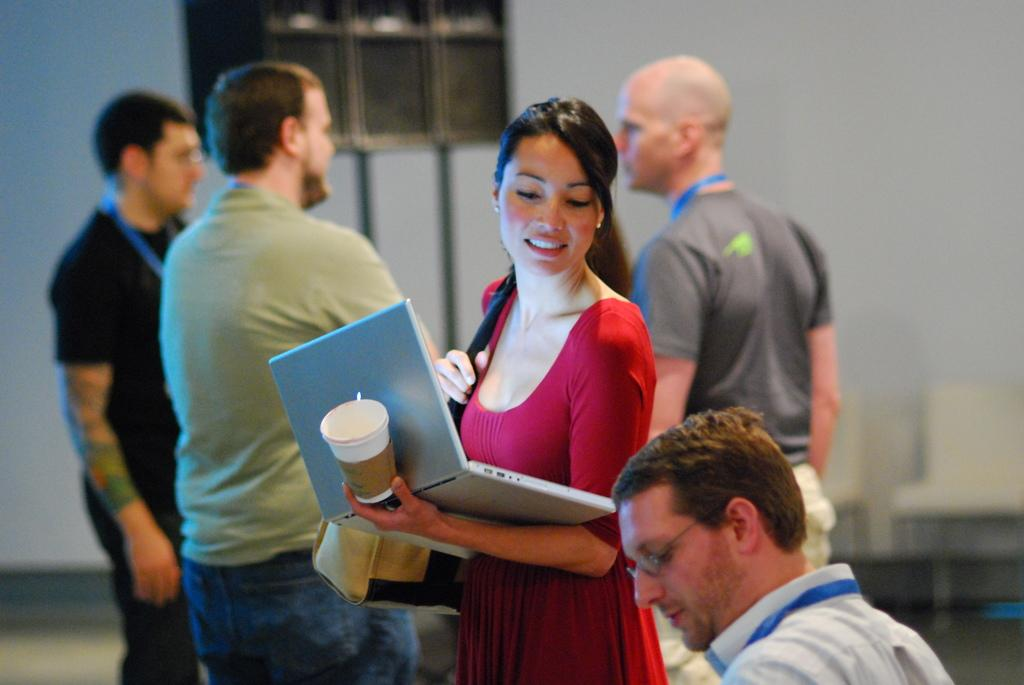What electronic device is visible in the image? There is a laptop in the image. What type of container is present in the image? There is a glass in the image. What type of personal item can be seen in the image? There is a bag in the image. What type of identification is visible in the image? There are ID tags in the image. What type of furniture is present in the image? There are chairs in the image. Are there any people in the image? Yes, there are people standing in the image. What can be seen in the background of the image? There is an object and a wall in the background of the image. What type of cream is being spread on the wall in the image? There is no cream being spread on the wall in the image. What type of sound can be heard coming from the object in the background of the image? There is no sound present in the image, so it cannot be determined what sound might be heard. 